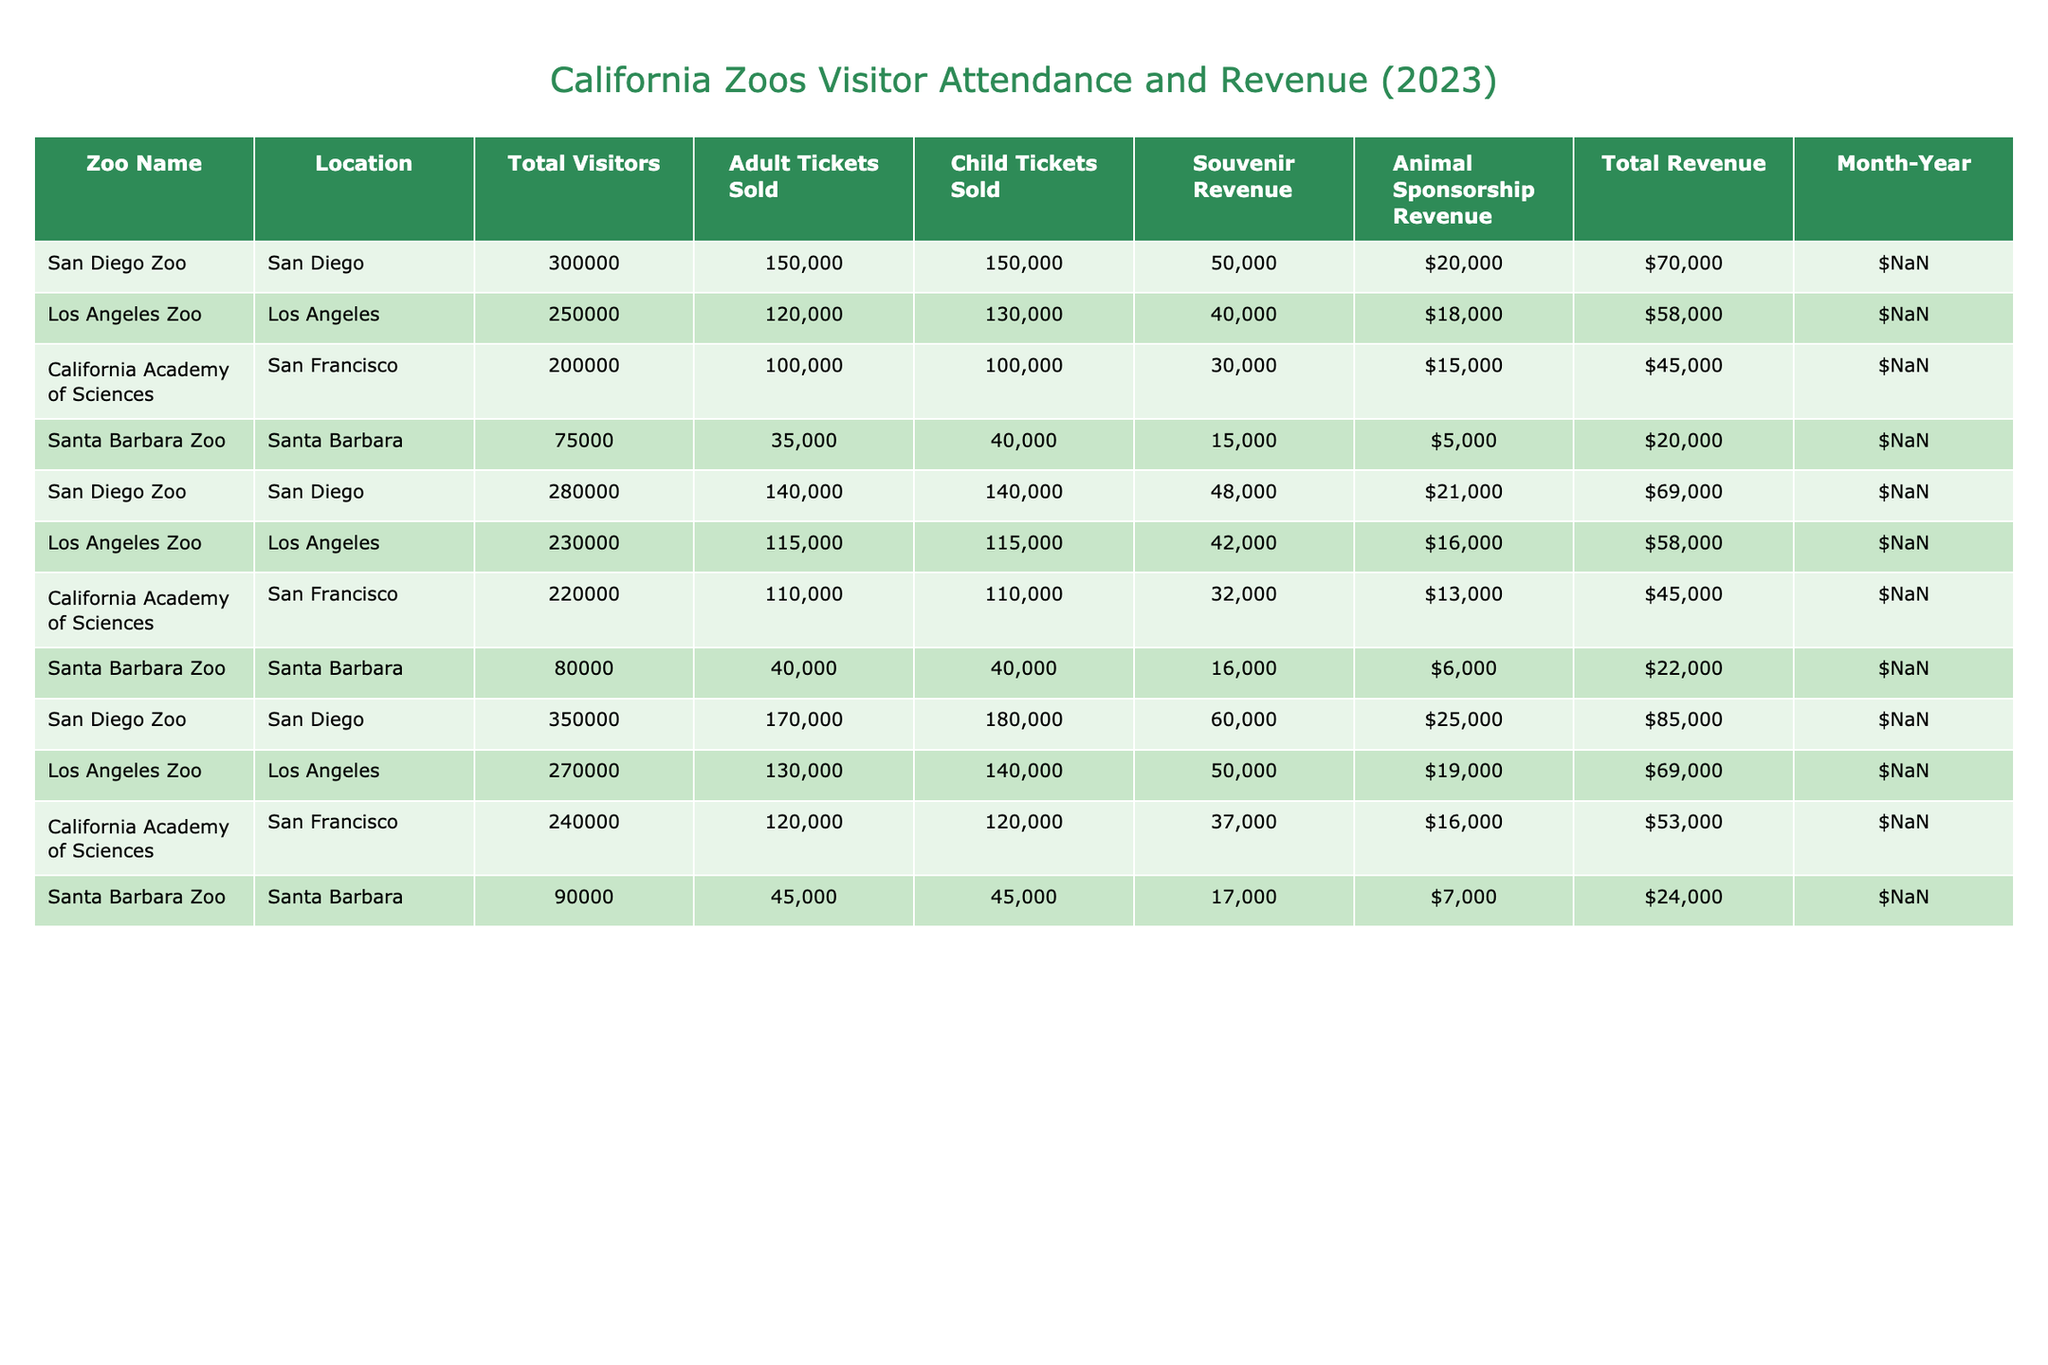What is the total number of visitors at the San Diego Zoo in March? In March, the total visitors at the San Diego Zoo are reported as 350,000 according to the table.
Answer: 350,000 What was the souvenir revenue for the California Academy of Sciences in January? The souvenir revenue for the California Academy of Sciences in January is listed as 30,000 in the table.
Answer: 30,000 Which zoo had the highest total revenue in February? To find the highest total revenue in February, we need to add the souvenir revenue and animal sponsorship revenue for each zoo. For San Diego Zoo, it's 48,000 + 21,000 = 69,000; Los Angeles Zoo is 42,000 + 16,000 = 58,000; California Academy of Sciences is 32,000 + 13,000 = 45,000; Santa Barbara Zoo is 16,000 + 6,000 = 22,000. San Diego Zoo has the highest total revenue of 69,000.
Answer: San Diego Zoo What was the average number of adult tickets sold across all zoos in January? The adult tickets sold in January are 150,000 (San Diego Zoo) + 120,000 (Los Angeles Zoo) + 100,000 (California Academy of Sciences) + 35,000 (Santa Barbara Zoo) = 405,000. There are four zoos, so the average is 405,000 / 4 = 101,250.
Answer: 101,250 Did the Los Angeles Zoo sell more child tickets than the Santa Barbara Zoo in March? The Los Angeles Zoo sold 140,000 child tickets in March, while the Santa Barbara Zoo sold 45,000 child tickets. Since 140,000 is greater than 45,000, the statement is true.
Answer: Yes What is the total revenue for all zoos in January? To find the total revenue for all zoos in January, we need to calculate the sum of each zoo's souvenir revenue and animal sponsorship revenue: San Diego Zoo (50,000 + 20,000) + Los Angeles Zoo (40,000 + 18,000) + California Academy of Sciences (30,000 + 15,000) + Santa Barbara Zoo (15,000 + 5,000) = 70,000 + 58,000 + 45,000 + 20,000 = 193,000.
Answer: 193,000 Which month had the highest total number of visitors across all zoos? We need to sum the total visitors for each month. January has 300,000 + 250,000 + 200,000 + 75,000 = 825,000; February has 280,000 + 230,000 + 220,000 + 80,000 = 810,000; March has 350,000 + 270,000 + 240,000 + 90,000 = 950,000. Comparing these sums, March had the highest total visitors.
Answer: March What is the difference in total visitors between Los Angeles Zoo in January and March? The total visitors for Los Angeles Zoo in January is 250,000 and in March is 270,000. The difference is 270,000 - 250,000 = 20,000.
Answer: 20,000 